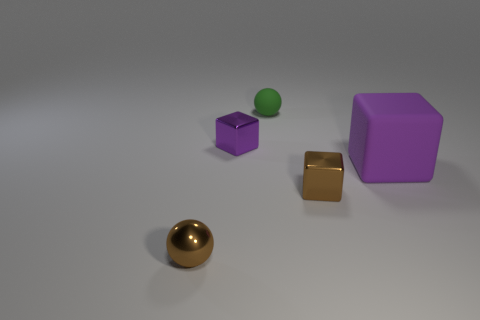Subtract all large matte cubes. How many cubes are left? 2 Add 3 spheres. How many objects exist? 8 Subtract all green spheres. How many purple blocks are left? 2 Subtract all green balls. How many balls are left? 1 Subtract all cubes. How many objects are left? 2 Subtract 1 blocks. How many blocks are left? 2 Add 3 small brown objects. How many small brown objects are left? 5 Add 2 tiny purple cubes. How many tiny purple cubes exist? 3 Subtract 0 yellow cylinders. How many objects are left? 5 Subtract all blue spheres. Subtract all green cylinders. How many spheres are left? 2 